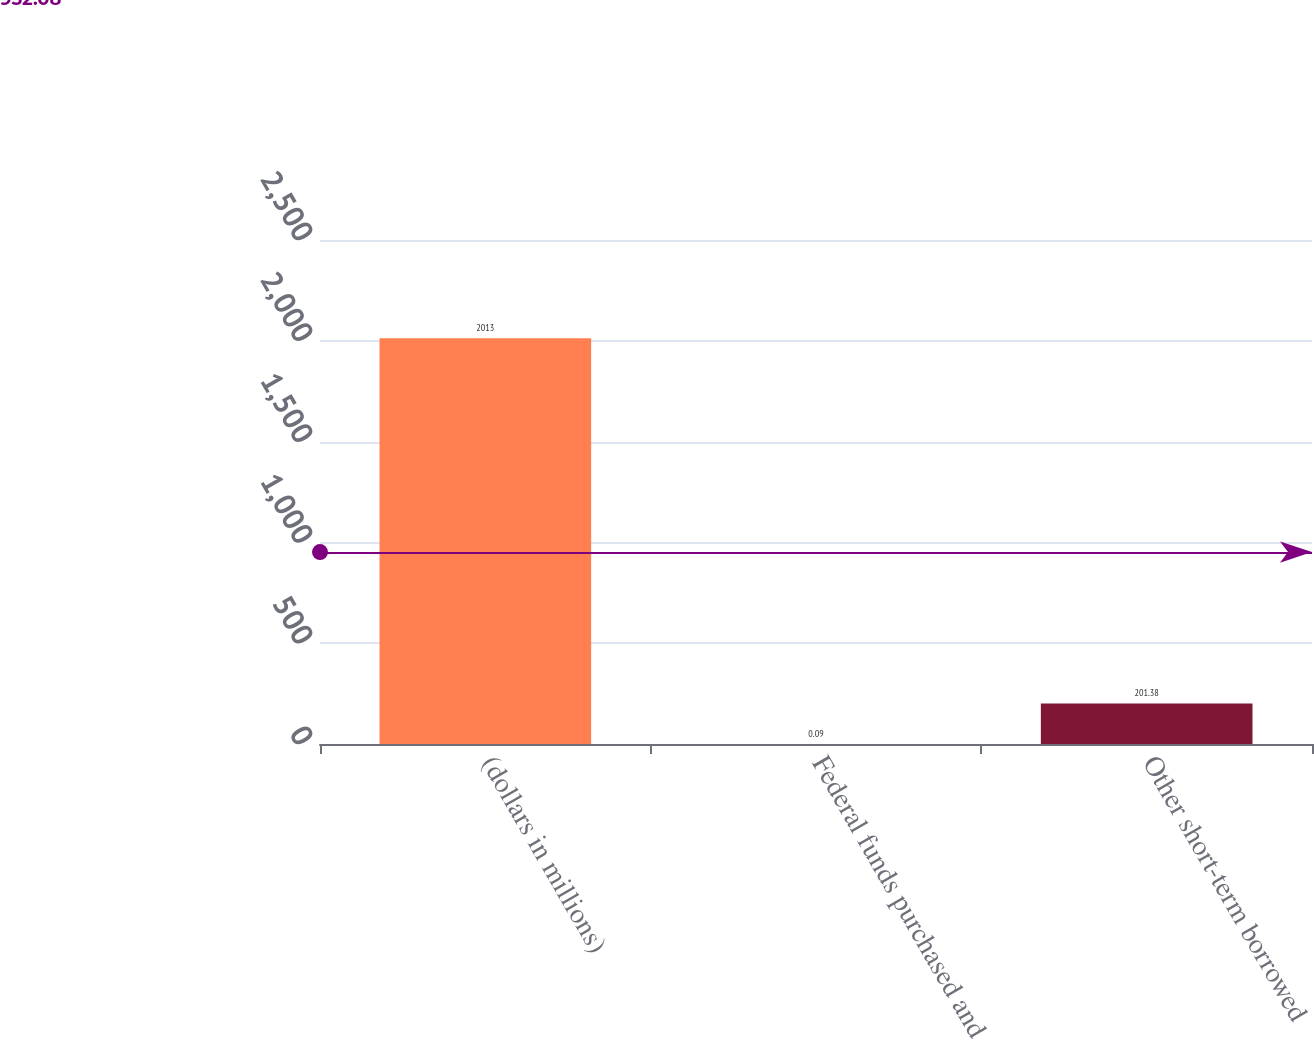Convert chart to OTSL. <chart><loc_0><loc_0><loc_500><loc_500><bar_chart><fcel>(dollars in millions)<fcel>Federal funds purchased and<fcel>Other short-term borrowed<nl><fcel>2013<fcel>0.09<fcel>201.38<nl></chart> 